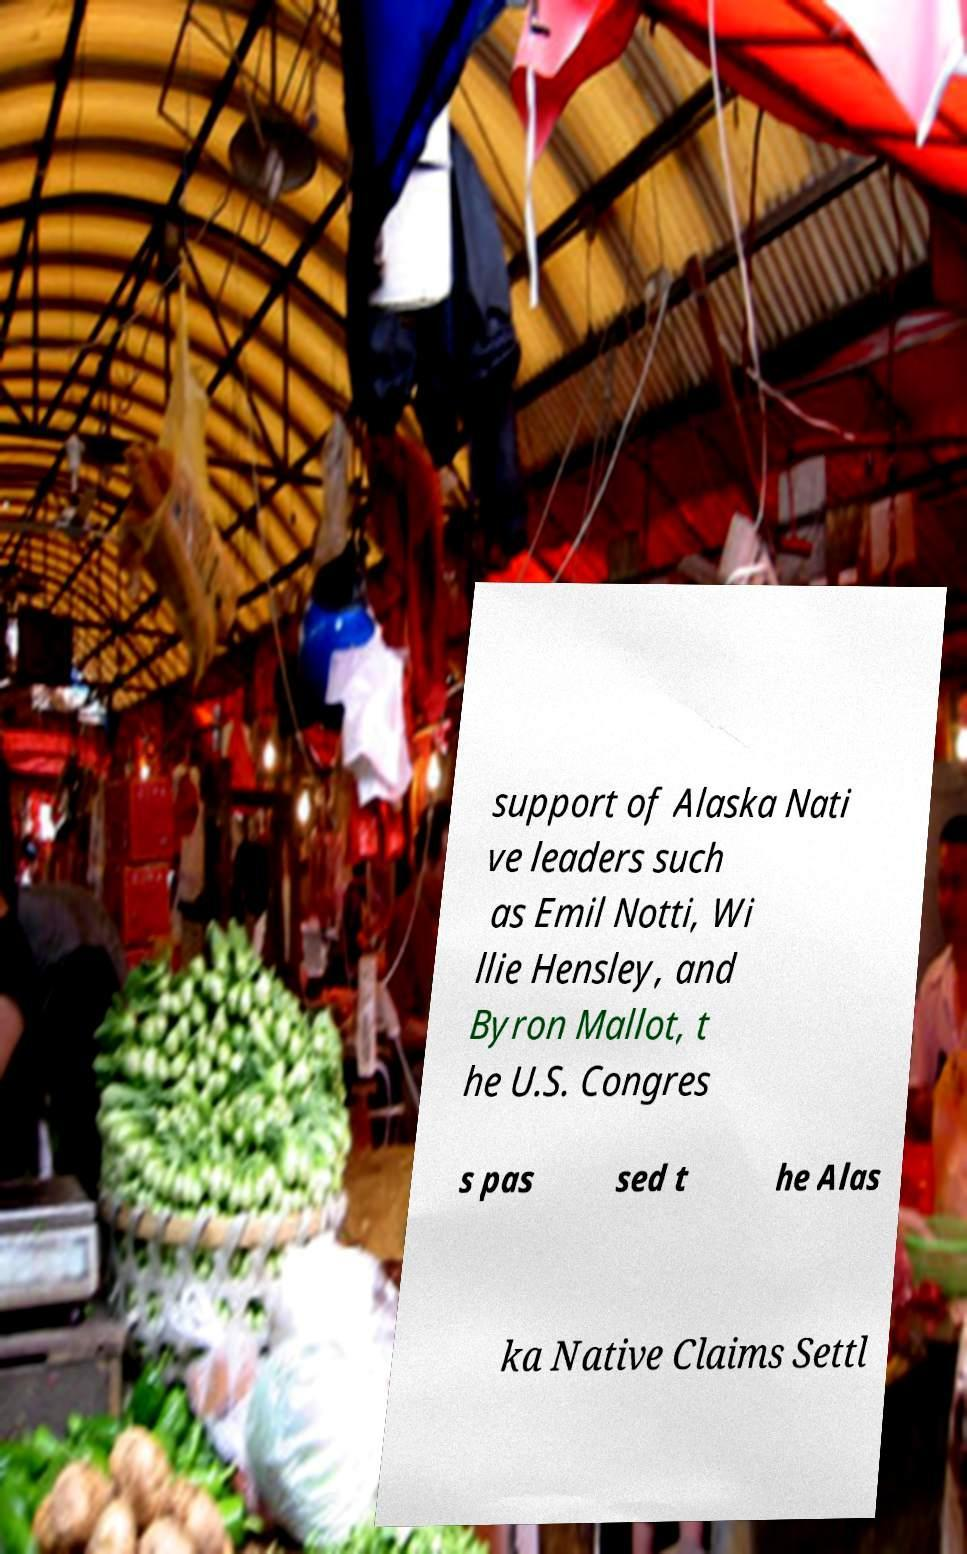Please read and relay the text visible in this image. What does it say? support of Alaska Nati ve leaders such as Emil Notti, Wi llie Hensley, and Byron Mallot, t he U.S. Congres s pas sed t he Alas ka Native Claims Settl 